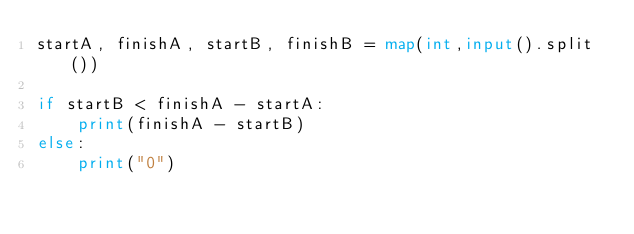<code> <loc_0><loc_0><loc_500><loc_500><_Python_>startA, finishA, startB, finishB = map(int,input().split())

if startB < finishA - startA:
    print(finishA - startB)
else:
    print("0")
</code> 